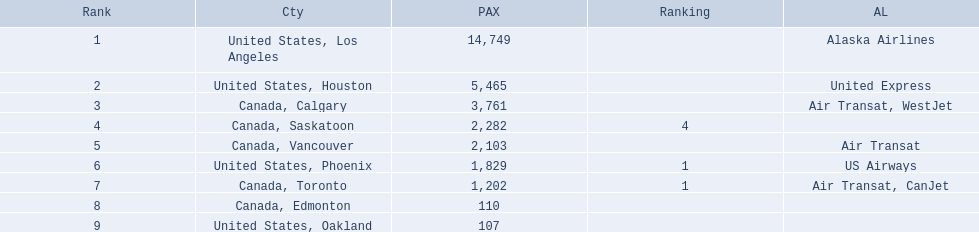What are the cities flown to? United States, Los Angeles, United States, Houston, Canada, Calgary, Canada, Saskatoon, Canada, Vancouver, United States, Phoenix, Canada, Toronto, Canada, Edmonton, United States, Oakland. What number of passengers did pheonix have? 1,829. 